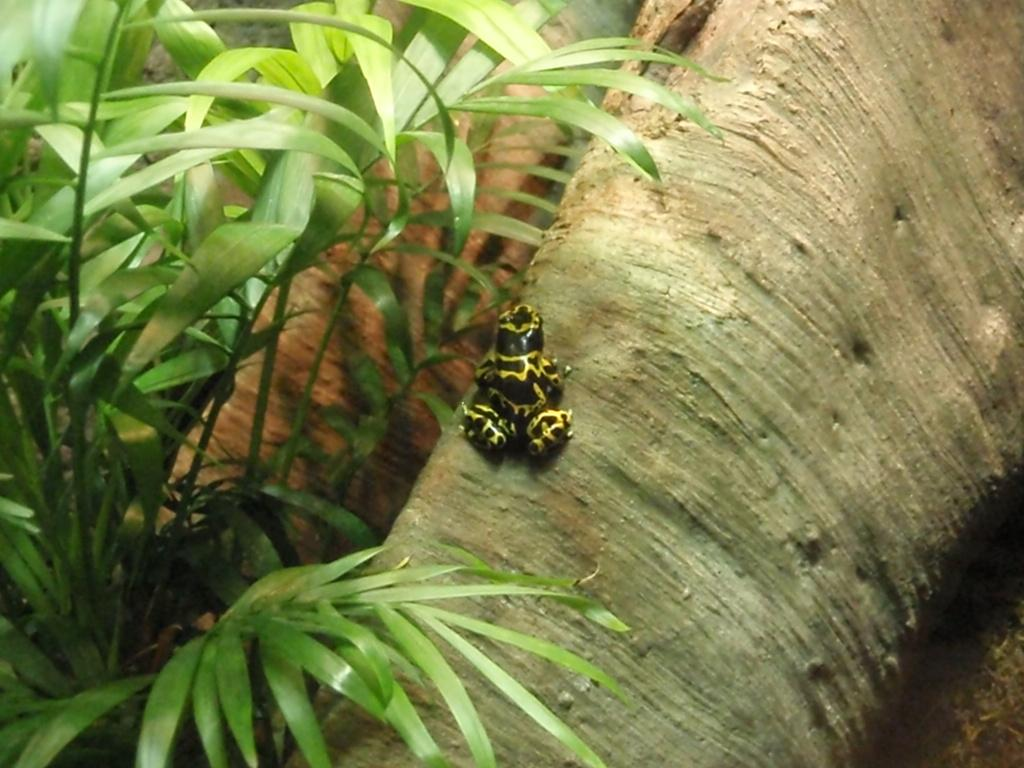What is on the tree trunk in the image? There is an insect on the tree trunk in the image. What type of vegetation can be seen in the image? There are many plants visible in the image. Who is the owner of the unit in the image? There is no unit or owner mentioned in the image; it features an insect on a tree trunk and many plants. 